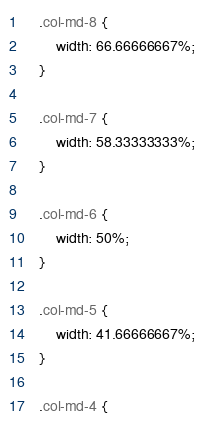Convert code to text. <code><loc_0><loc_0><loc_500><loc_500><_CSS_>
    .col-md-8 {
        width: 66.66666667%;
    }

    .col-md-7 {
        width: 58.33333333%;
    }

    .col-md-6 {
        width: 50%;
    }

    .col-md-5 {
        width: 41.66666667%;
    }

    .col-md-4 {</code> 